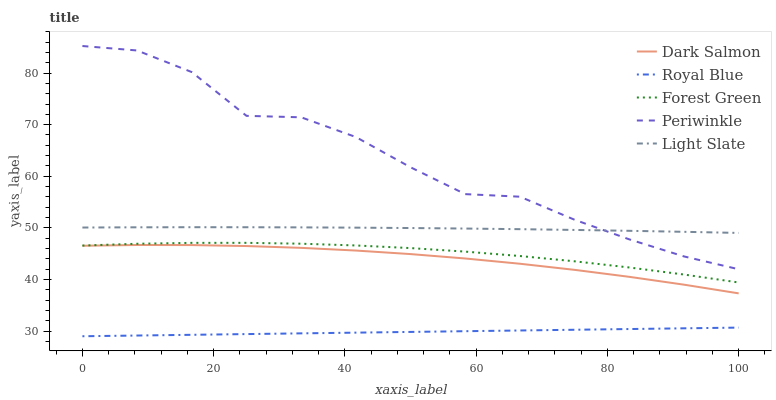Does Royal Blue have the minimum area under the curve?
Answer yes or no. Yes. Does Periwinkle have the maximum area under the curve?
Answer yes or no. Yes. Does Forest Green have the minimum area under the curve?
Answer yes or no. No. Does Forest Green have the maximum area under the curve?
Answer yes or no. No. Is Royal Blue the smoothest?
Answer yes or no. Yes. Is Periwinkle the roughest?
Answer yes or no. Yes. Is Forest Green the smoothest?
Answer yes or no. No. Is Forest Green the roughest?
Answer yes or no. No. Does Royal Blue have the lowest value?
Answer yes or no. Yes. Does Forest Green have the lowest value?
Answer yes or no. No. Does Periwinkle have the highest value?
Answer yes or no. Yes. Does Forest Green have the highest value?
Answer yes or no. No. Is Dark Salmon less than Periwinkle?
Answer yes or no. Yes. Is Periwinkle greater than Dark Salmon?
Answer yes or no. Yes. Does Light Slate intersect Periwinkle?
Answer yes or no. Yes. Is Light Slate less than Periwinkle?
Answer yes or no. No. Is Light Slate greater than Periwinkle?
Answer yes or no. No. Does Dark Salmon intersect Periwinkle?
Answer yes or no. No. 